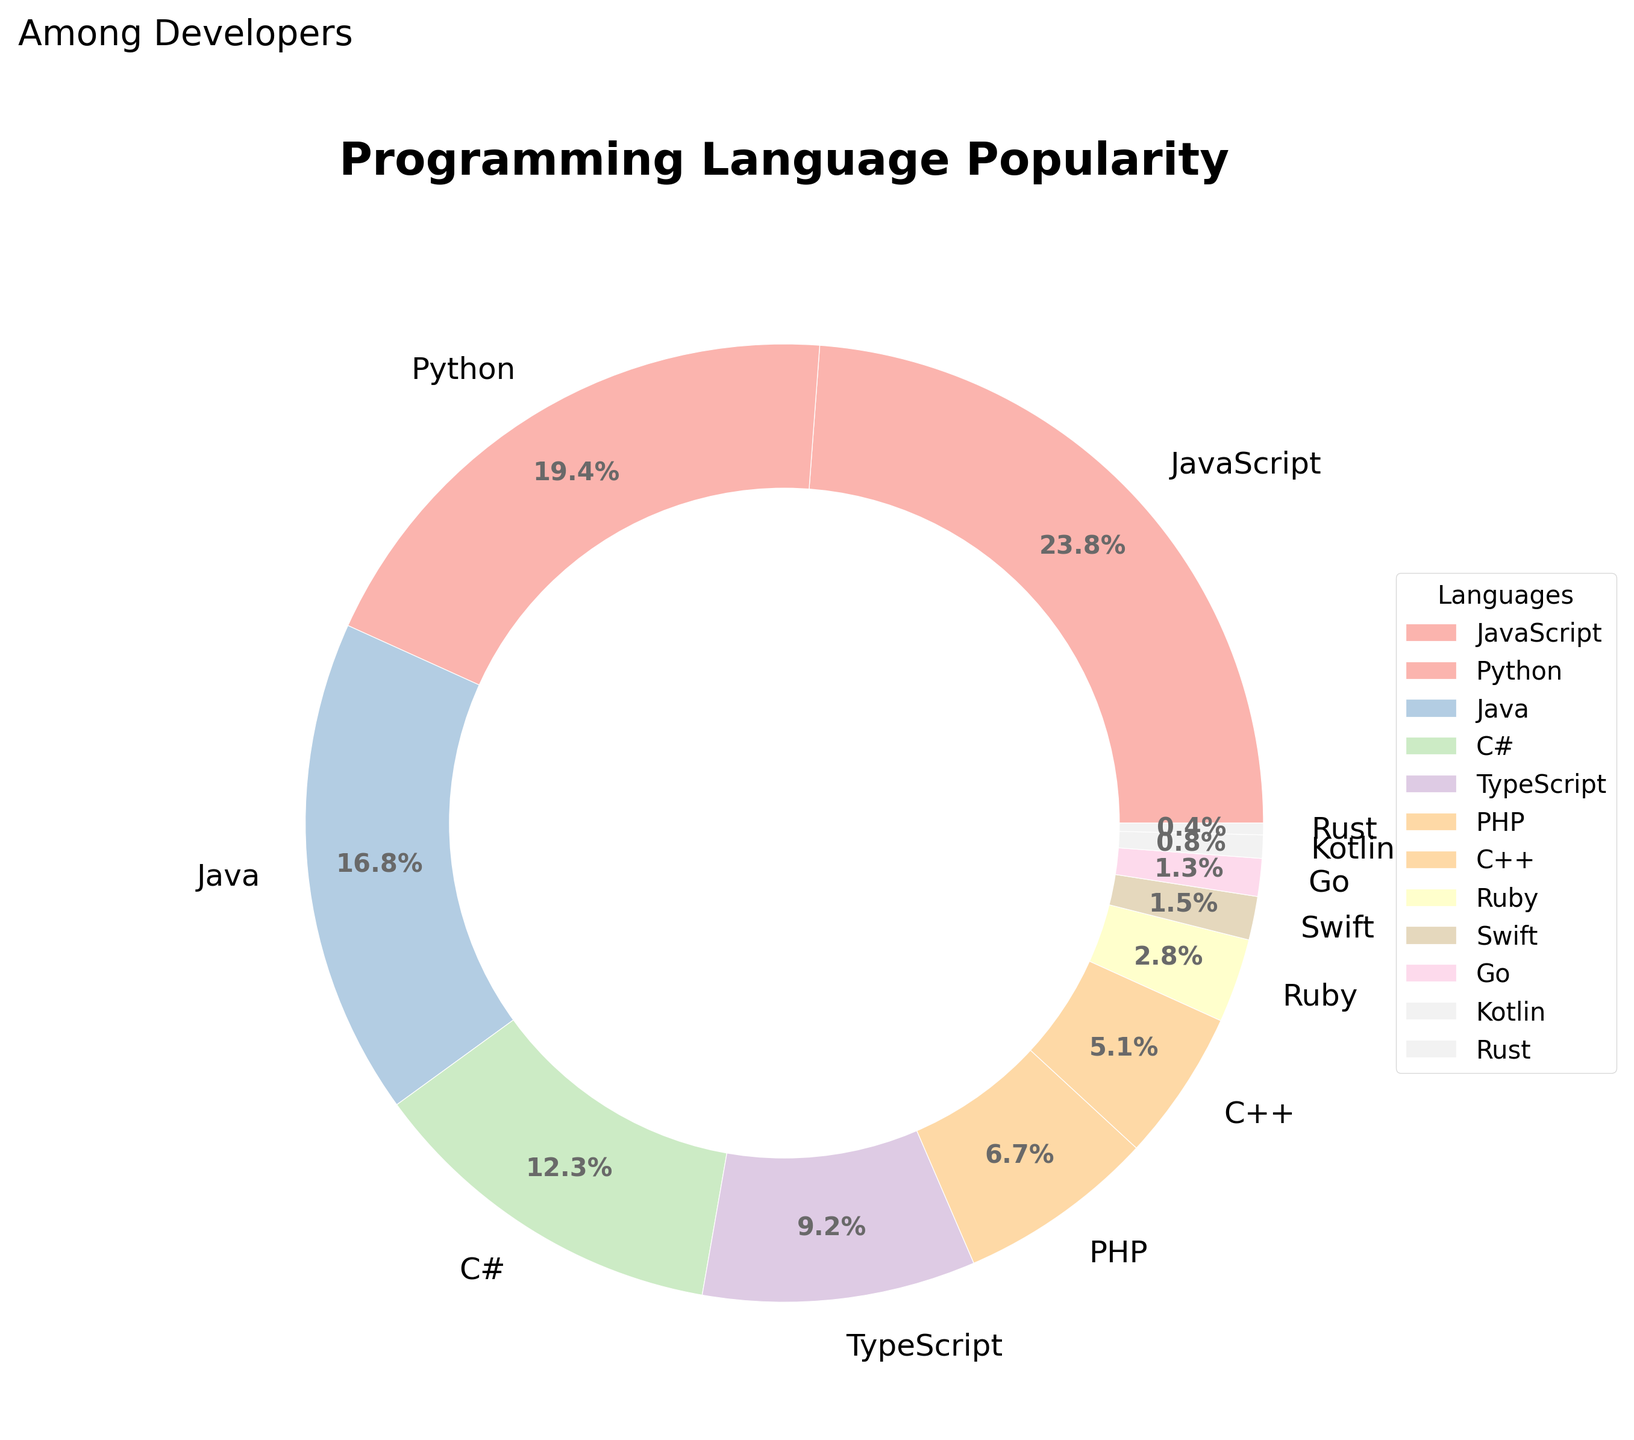Which programming language has the highest popularity among developers? The figure shows the percentages for each programming language, with the largest wedge representing the most popular language. JavaScript has the highest percentage at 24.3%.
Answer: JavaScript Which programming languages have a percentage less than 2%? Observing the wedges and their corresponding labels, Rust, Kotlin, and Go have percentages less than 2% with 0.4%, 0.8%, and 1.3% respectively.
Answer: Rust, Kotlin, Go What is the combined percentage of JavaScript, Python, and Java? Adding the percentages: JavaScript (24.3%) + Python (19.8%) + Java (17.1%) results in 61.2%.
Answer: 61.2% Is the percentage of TypeScript greater than C++? Comparing their respective wedges, TypeScript has a percentage of 9.4% while C++ has 5.2%, which means TypeScript is greater than C++.
Answer: Yes What is the average popularity of the bottom five languages? Adding the percentages of Ruby (2.9%), Swift (1.5%), Go (1.3%), Kotlin (0.8%), and Rust (0.4%) gives 6.9%. Dividing by the number of languages (5), the average is 1.38%.
Answer: 1.38% Which two languages together have a percentage closest to 20%? By examining the provided percentages, PHP (6.8%) and TypeScript (9.4%) collectively add to 16.2%, but Python (19.8%) is also near 20%.
Answer: Python (19.8%) What color is used for Python in the chart? Referring to the colors of the wedges in the pie chart, Python is represented by a specific pastel color from the color palette used (Pastel1). The exact color description should be observed directly in the chart for accuracy.
Answer: Pastel color (requires color observation) Is C++ more popular than Ruby? Comparing the percentages shown in their respective wedges, C++ has a percentage of 5.2% while Ruby has 2.9%. Thus, C++ is more popular.
Answer: Yes 